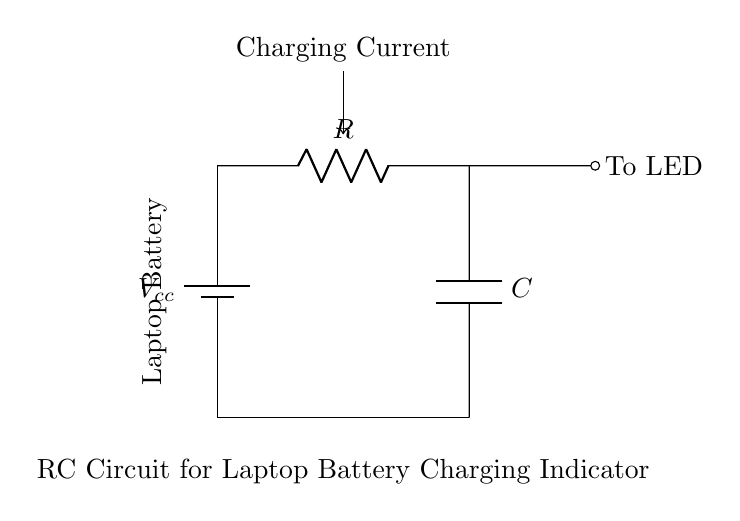What is the voltage source in this circuit? The circuit contains a battery labeled as Vcc, which indicates the voltage source used to charge the laptop battery.
Answer: Vcc What component is labeled with an R? The component labeled with an R is a resistor, which is used to limit the current in the circuit during the charging process.
Answer: Resistor What does the C represent in the circuit? The C in the circuit represents a capacitor, which stores electrical energy and helps smooth out voltage fluctuations.
Answer: Capacitor What does the LED indicate in this circuit? The LED is connected to the output of the RC circuit and serves as an indicator light to show that charging is occurring.
Answer: Charging indicator How does the charging current flow in this circuit? The charging current flows from the battery (Vcc) through the resistor, into the capacitor, and finally to the LED, indicating the battery is being charged.
Answer: From Vcc to LED What is the function of the resistor in this RC circuit? The resistor in this RC circuit limits the charging current to the capacitor, preventing damage to the circuit components and controlling the charging rate.
Answer: Limit charging current What role does the capacitor play in charging the laptop battery? The capacitor smooths the charging current and maintains the voltage across the LED, enhancing the stability of the charging indicator signal.
Answer: Smooths charging current 